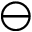Convert formula to latex. <formula><loc_0><loc_0><loc_500><loc_500>\ominus</formula> 